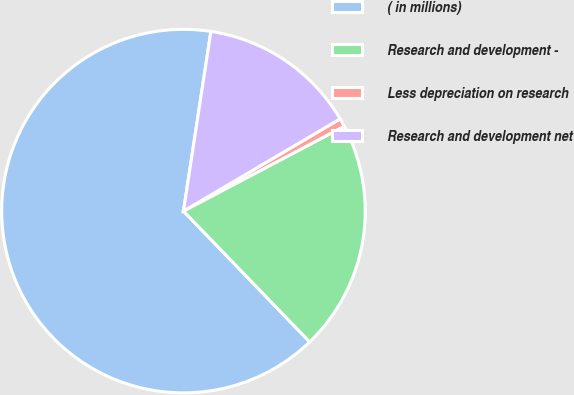Convert chart. <chart><loc_0><loc_0><loc_500><loc_500><pie_chart><fcel>( in millions)<fcel>Research and development -<fcel>Less depreciation on research<fcel>Research and development net<nl><fcel>64.63%<fcel>20.51%<fcel>0.74%<fcel>14.12%<nl></chart> 